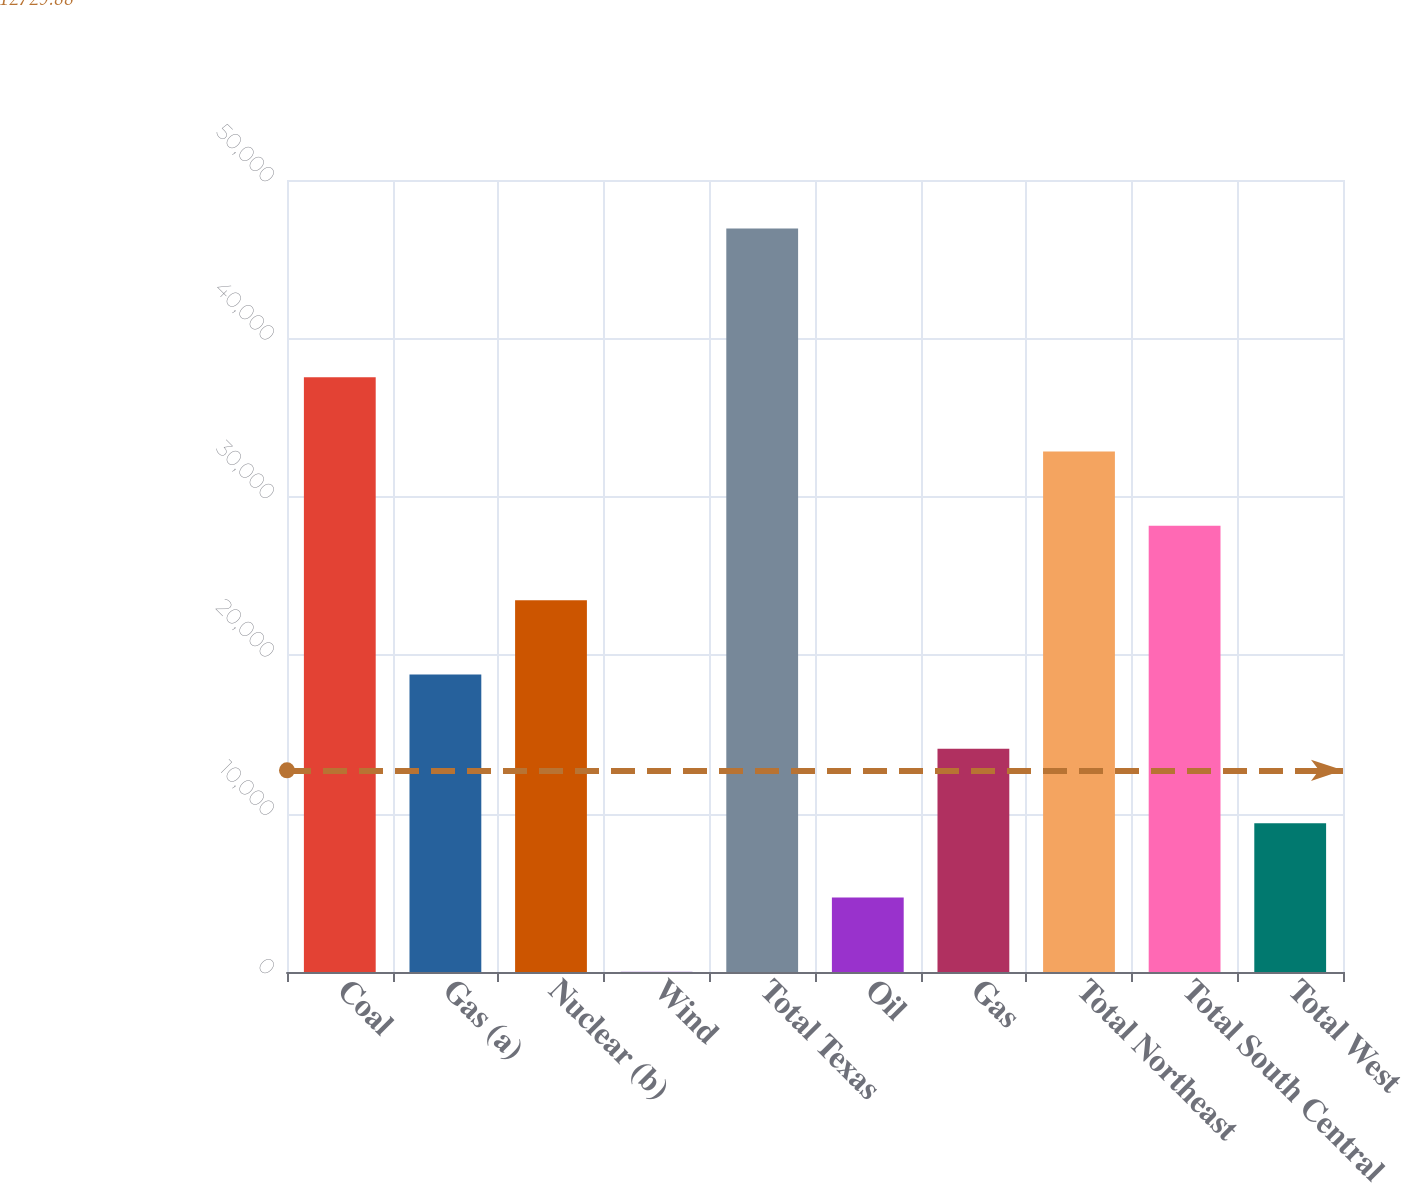<chart> <loc_0><loc_0><loc_500><loc_500><bar_chart><fcel>Coal<fcel>Gas (a)<fcel>Nuclear (b)<fcel>Wind<fcel>Total Texas<fcel>Oil<fcel>Gas<fcel>Total Northeast<fcel>Total South Central<fcel>Total West<nl><fcel>37551.4<fcel>18780.2<fcel>23473<fcel>9<fcel>46937<fcel>4701.8<fcel>14087.4<fcel>32858.6<fcel>28165.8<fcel>9394.6<nl></chart> 